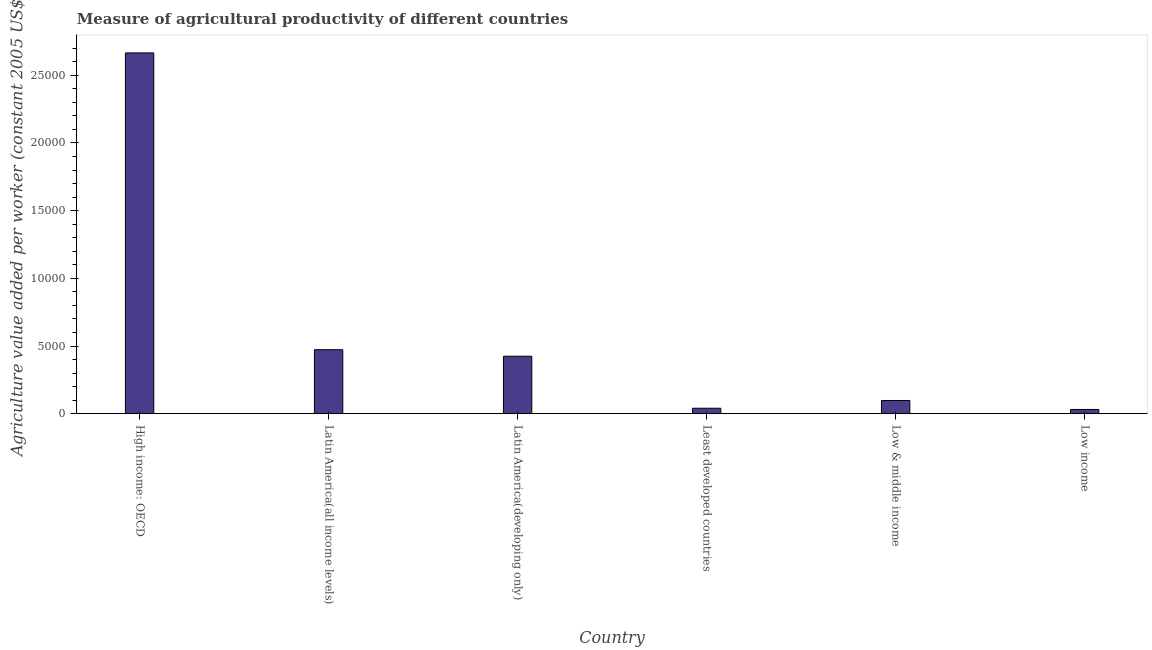Does the graph contain grids?
Offer a very short reply. No. What is the title of the graph?
Your answer should be very brief. Measure of agricultural productivity of different countries. What is the label or title of the Y-axis?
Give a very brief answer. Agriculture value added per worker (constant 2005 US$). What is the agriculture value added per worker in Least developed countries?
Your answer should be very brief. 406.07. Across all countries, what is the maximum agriculture value added per worker?
Your answer should be very brief. 2.66e+04. Across all countries, what is the minimum agriculture value added per worker?
Give a very brief answer. 315.53. In which country was the agriculture value added per worker maximum?
Ensure brevity in your answer.  High income: OECD. In which country was the agriculture value added per worker minimum?
Offer a very short reply. Low income. What is the sum of the agriculture value added per worker?
Keep it short and to the point. 3.73e+04. What is the difference between the agriculture value added per worker in Low & middle income and Low income?
Your response must be concise. 662.67. What is the average agriculture value added per worker per country?
Your response must be concise. 6220.91. What is the median agriculture value added per worker?
Keep it short and to the point. 2613.08. What is the ratio of the agriculture value added per worker in High income: OECD to that in Low & middle income?
Your answer should be compact. 27.24. Is the agriculture value added per worker in Latin America(all income levels) less than that in Low income?
Your answer should be very brief. No. Is the difference between the agriculture value added per worker in Latin America(all income levels) and Least developed countries greater than the difference between any two countries?
Make the answer very short. No. What is the difference between the highest and the second highest agriculture value added per worker?
Your response must be concise. 2.19e+04. What is the difference between the highest and the lowest agriculture value added per worker?
Offer a terse response. 2.63e+04. How many bars are there?
Offer a very short reply. 6. What is the difference between two consecutive major ticks on the Y-axis?
Your response must be concise. 5000. Are the values on the major ticks of Y-axis written in scientific E-notation?
Give a very brief answer. No. What is the Agriculture value added per worker (constant 2005 US$) in High income: OECD?
Provide a short and direct response. 2.66e+04. What is the Agriculture value added per worker (constant 2005 US$) in Latin America(all income levels)?
Provide a succinct answer. 4728.67. What is the Agriculture value added per worker (constant 2005 US$) of Latin America(developing only)?
Your answer should be very brief. 4247.95. What is the Agriculture value added per worker (constant 2005 US$) of Least developed countries?
Provide a succinct answer. 406.07. What is the Agriculture value added per worker (constant 2005 US$) in Low & middle income?
Make the answer very short. 978.2. What is the Agriculture value added per worker (constant 2005 US$) of Low income?
Your answer should be compact. 315.53. What is the difference between the Agriculture value added per worker (constant 2005 US$) in High income: OECD and Latin America(all income levels)?
Make the answer very short. 2.19e+04. What is the difference between the Agriculture value added per worker (constant 2005 US$) in High income: OECD and Latin America(developing only)?
Your answer should be compact. 2.24e+04. What is the difference between the Agriculture value added per worker (constant 2005 US$) in High income: OECD and Least developed countries?
Offer a terse response. 2.62e+04. What is the difference between the Agriculture value added per worker (constant 2005 US$) in High income: OECD and Low & middle income?
Your response must be concise. 2.57e+04. What is the difference between the Agriculture value added per worker (constant 2005 US$) in High income: OECD and Low income?
Offer a very short reply. 2.63e+04. What is the difference between the Agriculture value added per worker (constant 2005 US$) in Latin America(all income levels) and Latin America(developing only)?
Your answer should be compact. 480.71. What is the difference between the Agriculture value added per worker (constant 2005 US$) in Latin America(all income levels) and Least developed countries?
Give a very brief answer. 4322.6. What is the difference between the Agriculture value added per worker (constant 2005 US$) in Latin America(all income levels) and Low & middle income?
Keep it short and to the point. 3750.47. What is the difference between the Agriculture value added per worker (constant 2005 US$) in Latin America(all income levels) and Low income?
Provide a succinct answer. 4413.14. What is the difference between the Agriculture value added per worker (constant 2005 US$) in Latin America(developing only) and Least developed countries?
Your response must be concise. 3841.89. What is the difference between the Agriculture value added per worker (constant 2005 US$) in Latin America(developing only) and Low & middle income?
Provide a short and direct response. 3269.75. What is the difference between the Agriculture value added per worker (constant 2005 US$) in Latin America(developing only) and Low income?
Your answer should be very brief. 3932.42. What is the difference between the Agriculture value added per worker (constant 2005 US$) in Least developed countries and Low & middle income?
Your response must be concise. -572.13. What is the difference between the Agriculture value added per worker (constant 2005 US$) in Least developed countries and Low income?
Offer a very short reply. 90.54. What is the difference between the Agriculture value added per worker (constant 2005 US$) in Low & middle income and Low income?
Your response must be concise. 662.67. What is the ratio of the Agriculture value added per worker (constant 2005 US$) in High income: OECD to that in Latin America(all income levels)?
Your answer should be very brief. 5.64. What is the ratio of the Agriculture value added per worker (constant 2005 US$) in High income: OECD to that in Latin America(developing only)?
Your response must be concise. 6.27. What is the ratio of the Agriculture value added per worker (constant 2005 US$) in High income: OECD to that in Least developed countries?
Your answer should be very brief. 65.63. What is the ratio of the Agriculture value added per worker (constant 2005 US$) in High income: OECD to that in Low & middle income?
Offer a terse response. 27.24. What is the ratio of the Agriculture value added per worker (constant 2005 US$) in High income: OECD to that in Low income?
Provide a short and direct response. 84.46. What is the ratio of the Agriculture value added per worker (constant 2005 US$) in Latin America(all income levels) to that in Latin America(developing only)?
Your answer should be very brief. 1.11. What is the ratio of the Agriculture value added per worker (constant 2005 US$) in Latin America(all income levels) to that in Least developed countries?
Your answer should be compact. 11.64. What is the ratio of the Agriculture value added per worker (constant 2005 US$) in Latin America(all income levels) to that in Low & middle income?
Provide a short and direct response. 4.83. What is the ratio of the Agriculture value added per worker (constant 2005 US$) in Latin America(all income levels) to that in Low income?
Make the answer very short. 14.99. What is the ratio of the Agriculture value added per worker (constant 2005 US$) in Latin America(developing only) to that in Least developed countries?
Give a very brief answer. 10.46. What is the ratio of the Agriculture value added per worker (constant 2005 US$) in Latin America(developing only) to that in Low & middle income?
Provide a succinct answer. 4.34. What is the ratio of the Agriculture value added per worker (constant 2005 US$) in Latin America(developing only) to that in Low income?
Provide a succinct answer. 13.46. What is the ratio of the Agriculture value added per worker (constant 2005 US$) in Least developed countries to that in Low & middle income?
Your answer should be compact. 0.41. What is the ratio of the Agriculture value added per worker (constant 2005 US$) in Least developed countries to that in Low income?
Your response must be concise. 1.29. 